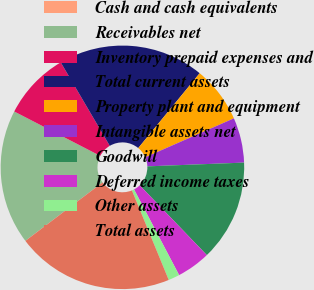Convert chart. <chart><loc_0><loc_0><loc_500><loc_500><pie_chart><fcel>Cash and cash equivalents<fcel>Receivables net<fcel>Inventory prepaid expenses and<fcel>Total current assets<fcel>Property plant and equipment<fcel>Intangible assets net<fcel>Goodwill<fcel>Deferred income taxes<fcel>Other assets<fcel>Total assets<nl><fcel>0.01%<fcel>17.9%<fcel>8.96%<fcel>19.39%<fcel>7.47%<fcel>5.97%<fcel>13.43%<fcel>4.48%<fcel>1.5%<fcel>20.88%<nl></chart> 